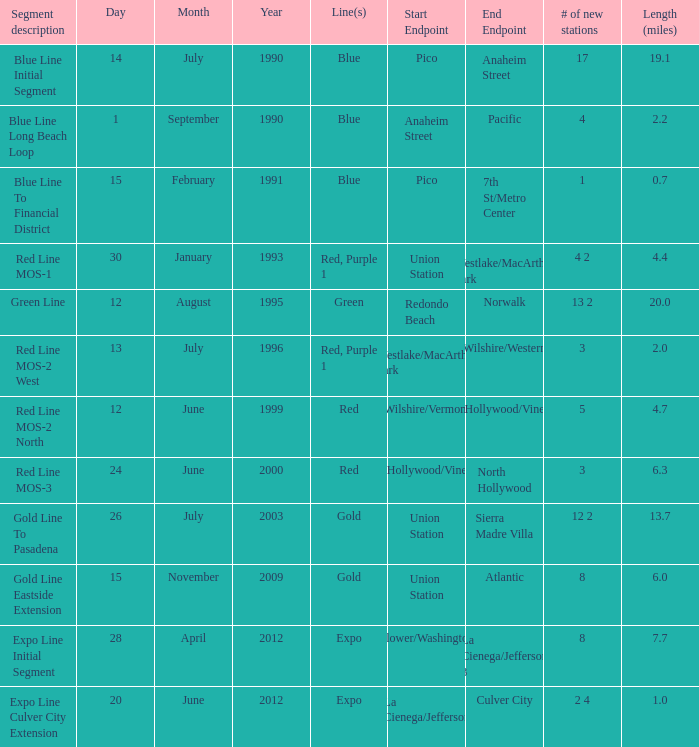Would you mind parsing the complete table? {'header': ['Segment description', 'Day', 'Month', 'Year', 'Line(s)', 'Start Endpoint', 'End Endpoint', '# of new stations', 'Length (miles)'], 'rows': [['Blue Line Initial Segment', '14', 'July', '1990', 'Blue', 'Pico', 'Anaheim Street', '17', '19.1'], ['Blue Line Long Beach Loop', '1', 'September', '1990', 'Blue', 'Anaheim Street', 'Pacific', '4', '2.2'], ['Blue Line To Financial District', '15', 'February', '1991', 'Blue', 'Pico', '7th St/Metro Center', '1', '0.7'], ['Red Line MOS-1', '30', 'January', '1993', 'Red, Purple 1', 'Union Station', 'Westlake/MacArthur Park', '4 2', '4.4'], ['Green Line', '12', 'August', '1995', 'Green', 'Redondo Beach', 'Norwalk', '13 2', '20.0'], ['Red Line MOS-2 West', '13', 'July', '1996', 'Red, Purple 1', 'Westlake/MacArthur Park', 'Wilshire/Western', '3', '2.0'], ['Red Line MOS-2 North', '12', 'June', '1999', 'Red', 'Wilshire/Vermont', 'Hollywood/Vine', '5', '4.7'], ['Red Line MOS-3', '24', 'June', '2000', 'Red', 'Hollywood/Vine', 'North Hollywood', '3', '6.3'], ['Gold Line To Pasadena', '26', 'July', '2003', 'Gold', 'Union Station', 'Sierra Madre Villa', '12 2', '13.7'], ['Gold Line Eastside Extension', '15', 'November', '2009', 'Gold', 'Union Station', 'Atlantic', '8', '6.0'], ['Expo Line Initial Segment', '28', 'April', '2012', 'Expo', 'Flower/Washington', 'La Cienega/Jefferson 3', '8', '7.7'], ['Expo Line Culver City Extension', '20', 'June', '2012', 'Expo', 'La Cienega/Jefferson', 'Culver City', '2 4', '1.0']]} How many news stations opened on the date of June 24, 2000? 3.0. 